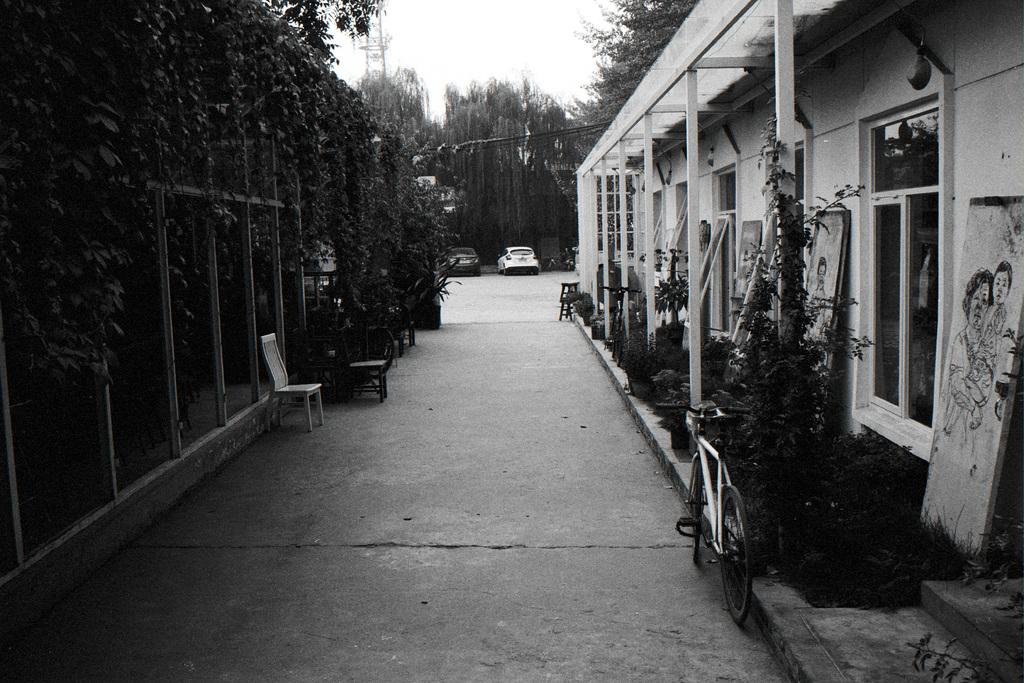What type of structures can be seen in the image? There are buildings in the image. What architectural features are visible on the buildings? There are windows in the image. What natural elements are present in the image? There are trees in the image. What man-made objects can be seen in the image? There are vehicles and bicycles in the image. What type of furniture is visible in the image? There are chairs in the image. What part of the natural environment is visible in the image? The sky is visible in the image. Are there any stairs visible in the image? Yes, there are stairs in the image. What is the color scheme of the image? The image is black and white. Can you tell me how many bags are being used for comfort during the argument in the image? There is no mention of bags, comfort, or an argument in the image. The image is black and white and features buildings, windows, trees, vehicles, bicycles, chairs, stairs, and a visible sky. 